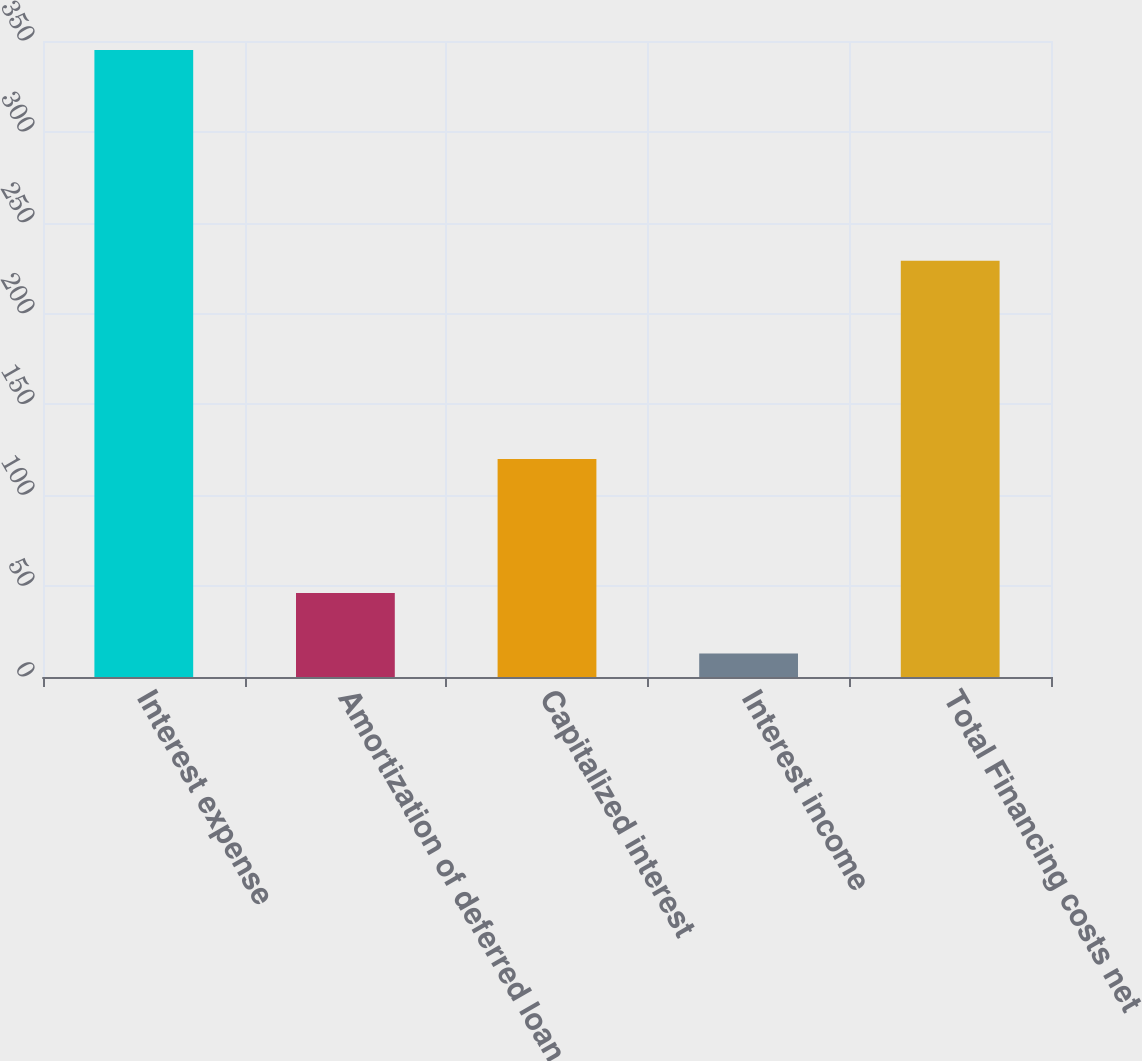<chart> <loc_0><loc_0><loc_500><loc_500><bar_chart><fcel>Interest expense<fcel>Amortization of deferred loan<fcel>Capitalized interest<fcel>Interest income<fcel>Total Financing costs net<nl><fcel>345<fcel>46.2<fcel>120<fcel>13<fcel>229<nl></chart> 